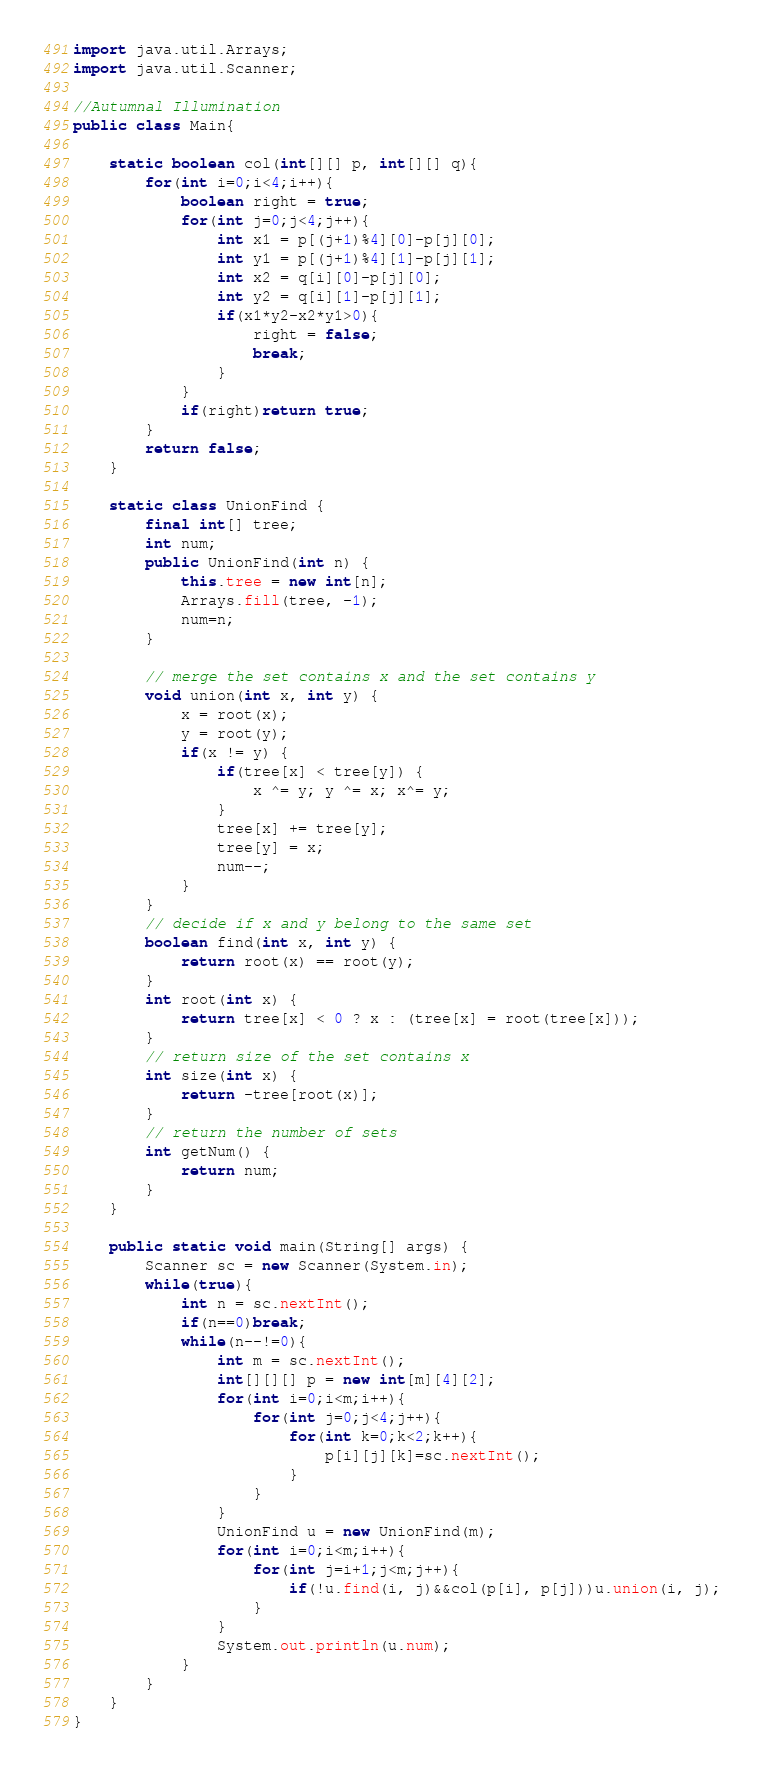<code> <loc_0><loc_0><loc_500><loc_500><_Java_>import java.util.Arrays;
import java.util.Scanner;

//Autumnal Illumination
public class Main{

	static boolean col(int[][] p, int[][] q){
		for(int i=0;i<4;i++){
			boolean right = true;
			for(int j=0;j<4;j++){
				int x1 = p[(j+1)%4][0]-p[j][0];
				int y1 = p[(j+1)%4][1]-p[j][1];
				int x2 = q[i][0]-p[j][0];
				int y2 = q[i][1]-p[j][1];
				if(x1*y2-x2*y1>0){
					right = false;
					break;
				}
			}
			if(right)return true;
		}
		return false;
	}

	static class UnionFind {
		final int[] tree;
		int num;
		public UnionFind(int n) {
			this.tree = new int[n];
			Arrays.fill(tree, -1);
			num=n;
		}

		// merge the set contains x and the set contains y
		void union(int x, int y) {
			x = root(x);
			y = root(y);
			if(x != y) {
				if(tree[x] < tree[y]) {
					x ^= y; y ^= x; x^= y;
				}
				tree[x] += tree[y];
				tree[y] = x;
				num--;
			}
		}
		// decide if x and y belong to the same set
		boolean find(int x, int y) {
			return root(x) == root(y);
		}
		int root(int x) {
			return tree[x] < 0 ? x : (tree[x] = root(tree[x]));
		}
		// return size of the set contains x
		int size(int x) {
			return -tree[root(x)];
		}
		// return the number of sets
		int getNum() {
			return num;
		}
	}
	
	public static void main(String[] args) {
		Scanner sc = new Scanner(System.in);
		while(true){
			int n = sc.nextInt();
			if(n==0)break;
			while(n--!=0){
				int m = sc.nextInt();
				int[][][] p = new int[m][4][2];
				for(int i=0;i<m;i++){
					for(int j=0;j<4;j++){
						for(int k=0;k<2;k++){
							p[i][j][k]=sc.nextInt();
						}
					}
				}
				UnionFind u = new UnionFind(m);
				for(int i=0;i<m;i++){
					for(int j=i+1;j<m;j++){
						if(!u.find(i, j)&&col(p[i], p[j]))u.union(i, j);
					}
				}
				System.out.println(u.num);
			}
		}
	}
}</code> 